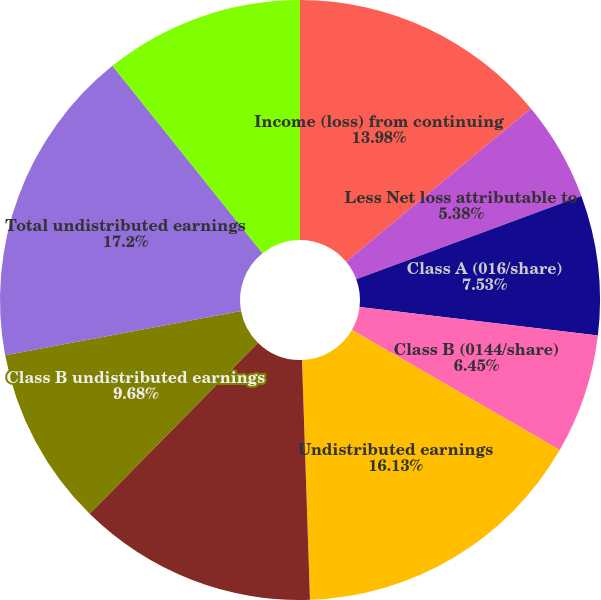<chart> <loc_0><loc_0><loc_500><loc_500><pie_chart><fcel>Income (loss) from continuing<fcel>Less Net loss attributable to<fcel>Class A (016/share)<fcel>Class B (0144/share)<fcel>Undistributed earnings<fcel>Class A undistributed earnings<fcel>Class B undistributed earnings<fcel>Total undistributed earnings<fcel>Class A weighted average<nl><fcel>13.98%<fcel>5.38%<fcel>7.53%<fcel>6.45%<fcel>16.13%<fcel>12.9%<fcel>9.68%<fcel>17.2%<fcel>10.75%<nl></chart> 